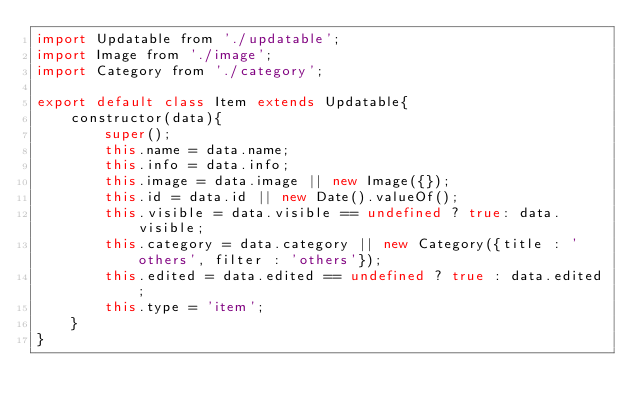<code> <loc_0><loc_0><loc_500><loc_500><_JavaScript_>import Updatable from './updatable';
import Image from './image'; 
import Category from './category';

export default class Item extends Updatable{
	constructor(data){
		super();
		this.name = data.name; 
		this.info = data.info;  
		this.image = data.image || new Image({}); 
		this.id = data.id || new Date().valueOf();
		this.visible = data.visible == undefined ? true: data.visible;
		this.category = data.category || new Category({title : 'others', filter : 'others'}); 
		this.edited = data.edited == undefined ? true : data.edited;
		this.type = 'item';
	}
} </code> 